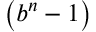<formula> <loc_0><loc_0><loc_500><loc_500>\left ( b ^ { n } - 1 \right )</formula> 